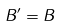Convert formula to latex. <formula><loc_0><loc_0><loc_500><loc_500>B ^ { \prime } = B</formula> 